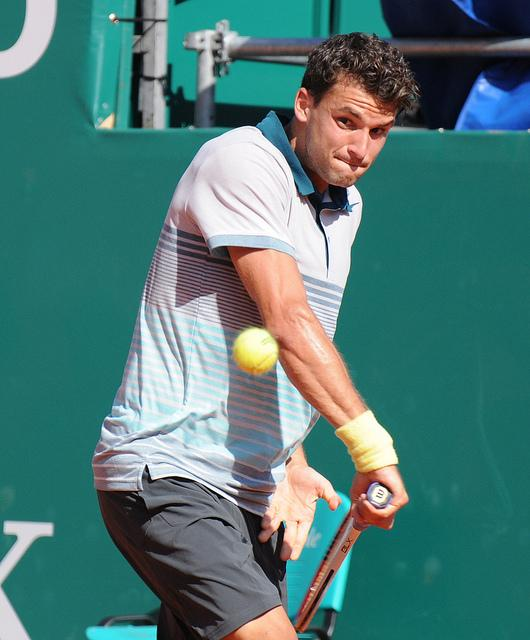What technique does this player utilize here? Please explain your reasoning. back handed. The players wrist is backwards and it is a typical motion of a band handed swing. 